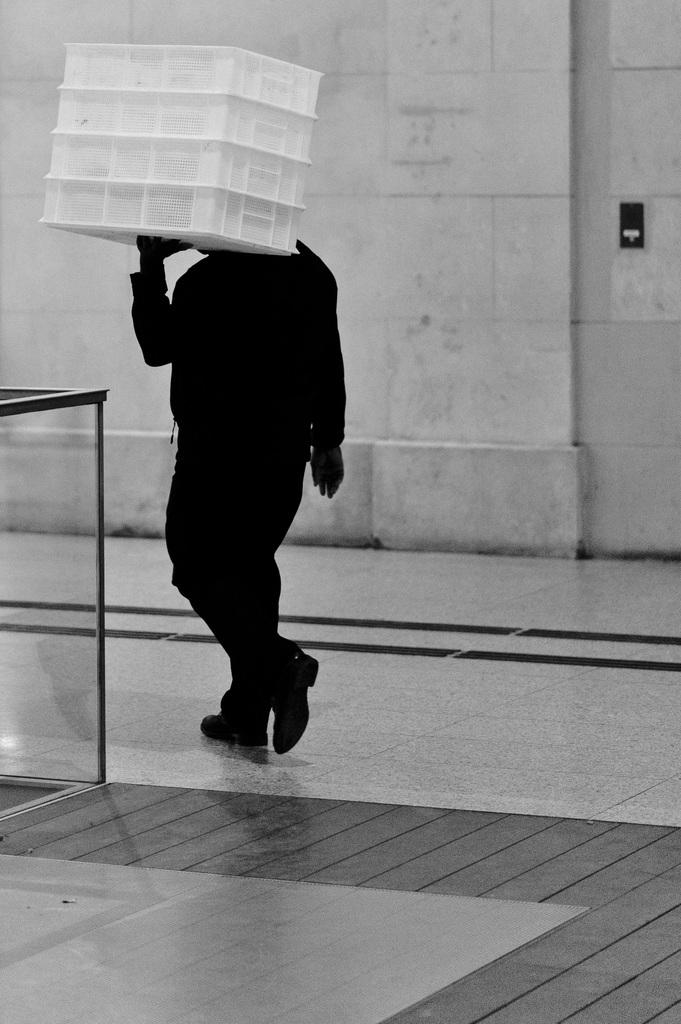What is the color scheme of the image? The image is black and white. Can you describe the main subject in the image? There is a person in the image. What is the person doing in the image? The person is carrying an object. What can be seen in the background of the image? There is a wall in the background of the image. What type of wave can be seen crashing on the shore in the image? There is no wave or shore present in the image; it is a black and white image featuring a person carrying an object with a wall in the background. 